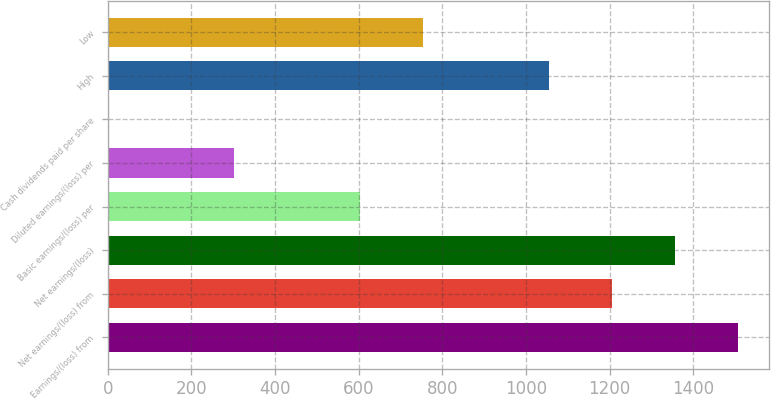Convert chart to OTSL. <chart><loc_0><loc_0><loc_500><loc_500><bar_chart><fcel>Earnings/(loss) from<fcel>Net earnings/(loss) from<fcel>Net earnings/(loss)<fcel>Basic earnings/(loss) per<fcel>Diluted earnings/(loss) per<fcel>Cash dividends paid per share<fcel>High<fcel>Low<nl><fcel>1506.03<fcel>1204.89<fcel>1355.46<fcel>602.62<fcel>301.49<fcel>0.35<fcel>1054.33<fcel>753.19<nl></chart> 